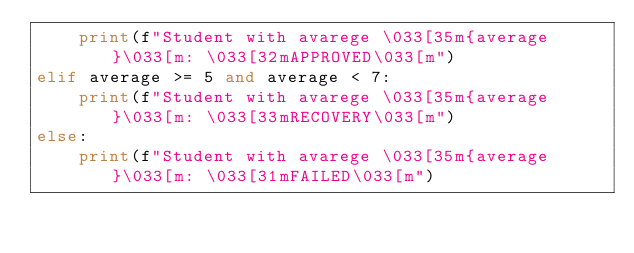<code> <loc_0><loc_0><loc_500><loc_500><_Python_>    print(f"Student with avarege \033[35m{average}\033[m: \033[32mAPPROVED\033[m")
elif average >= 5 and average < 7:
    print(f"Student with avarege \033[35m{average}\033[m: \033[33mRECOVERY\033[m")
else:
    print(f"Student with avarege \033[35m{average}\033[m: \033[31mFAILED\033[m")</code> 